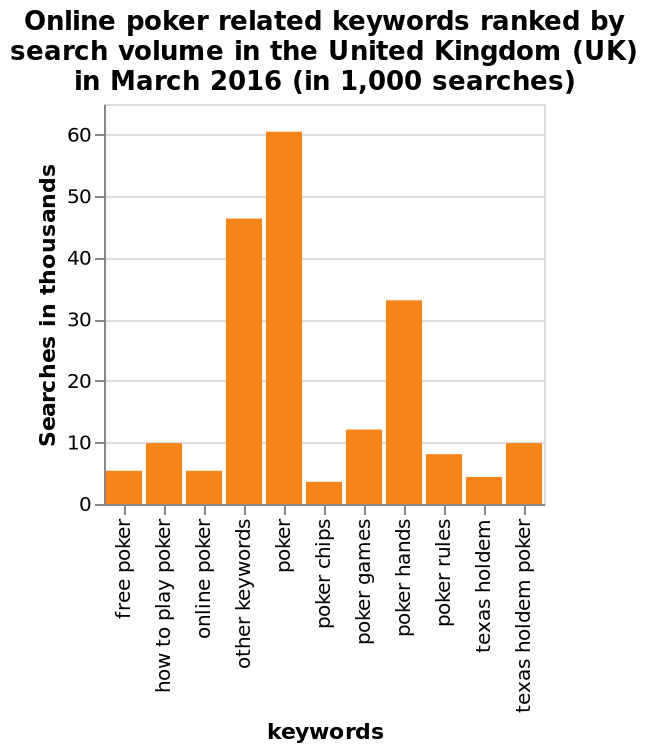<image>
What is the most popular search keyword related to poker?  The most popular search keyword related to poker is 'poker' with over 60,000 searches. How many searches were made for the keyword 'poker hands'?  Around 47,000 searches were made for the keyword 'poker hands'. What does the y-axis represent on the bar chart?  The y-axis on the bar chart represents the number of searches in thousands, ranging from 0 to 60. Which keyword had the highest search volume in March 2016? Without the specific data, it is impossible to determine the keyword with the highest search volume in March 2016. Does the y-axis on the bar chart represent the number of searches in millions, ranging from 0 to 60? No. The y-axis on the bar chart represents the number of searches in thousands, ranging from 0 to 60. 